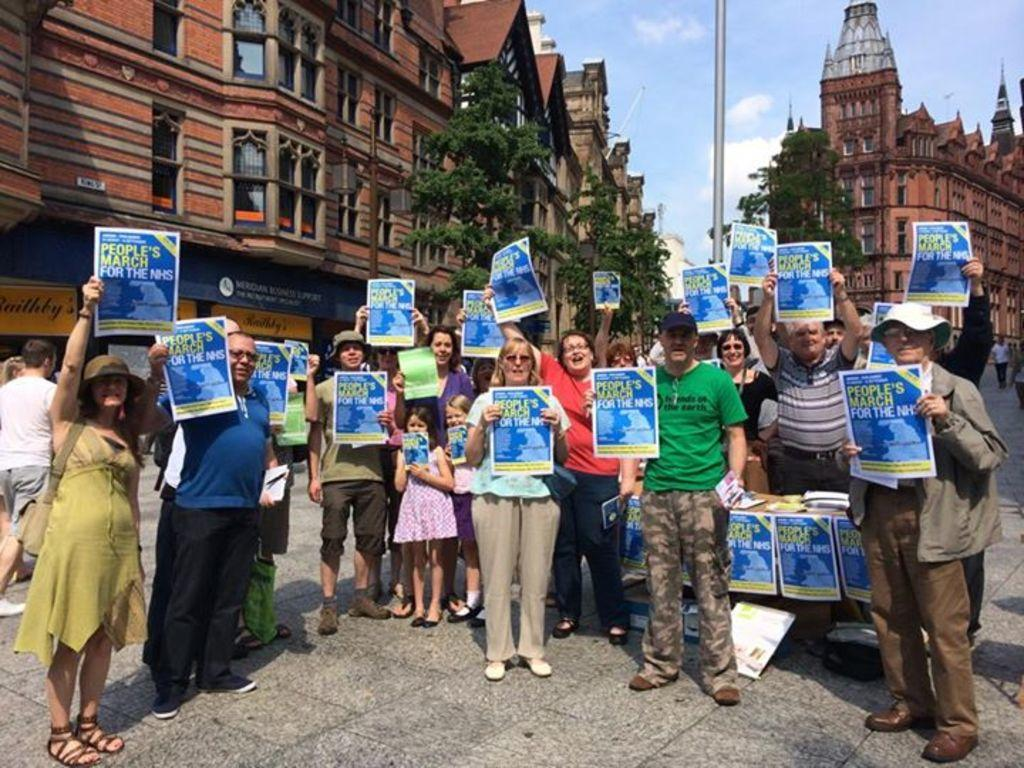What are the people in the image holding? The people in the image are holding posters. What can be found on the posters? The posters have text on them. Where is the setting of the image? The image is set on a road. What can be seen in the background of the image? There are trees, buildings, and the sky visible in the background of the image. How many dogs are sitting on the posters in the image? There are no dogs present on the posters or in the image. What type of brush is being used to paint the buildings in the background? There is no brush or painting activity depicted in the image; the buildings are already constructed. 